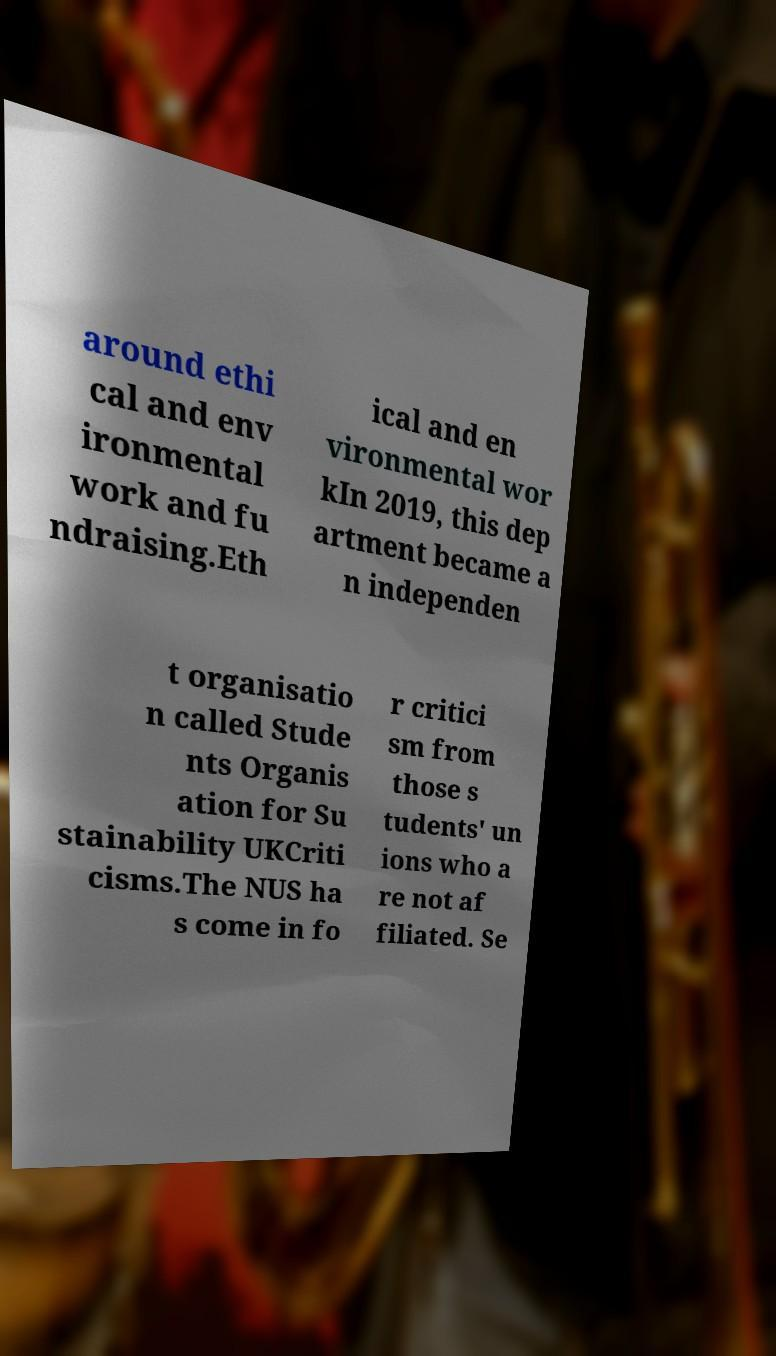Please read and relay the text visible in this image. What does it say? around ethi cal and env ironmental work and fu ndraising.Eth ical and en vironmental wor kIn 2019, this dep artment became a n independen t organisatio n called Stude nts Organis ation for Su stainability UKCriti cisms.The NUS ha s come in fo r critici sm from those s tudents' un ions who a re not af filiated. Se 